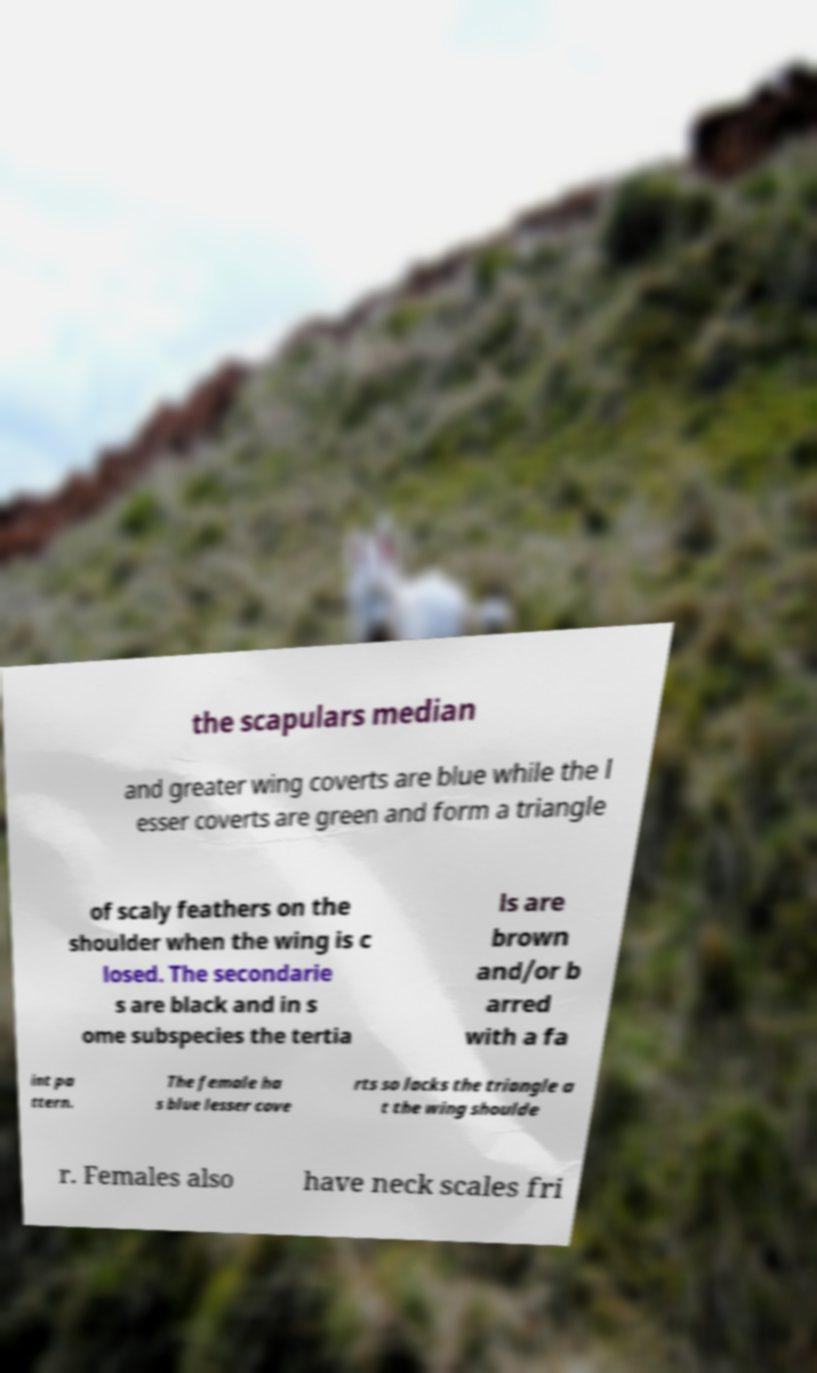Please identify and transcribe the text found in this image. the scapulars median and greater wing coverts are blue while the l esser coverts are green and form a triangle of scaly feathers on the shoulder when the wing is c losed. The secondarie s are black and in s ome subspecies the tertia ls are brown and/or b arred with a fa int pa ttern. The female ha s blue lesser cove rts so lacks the triangle a t the wing shoulde r. Females also have neck scales fri 